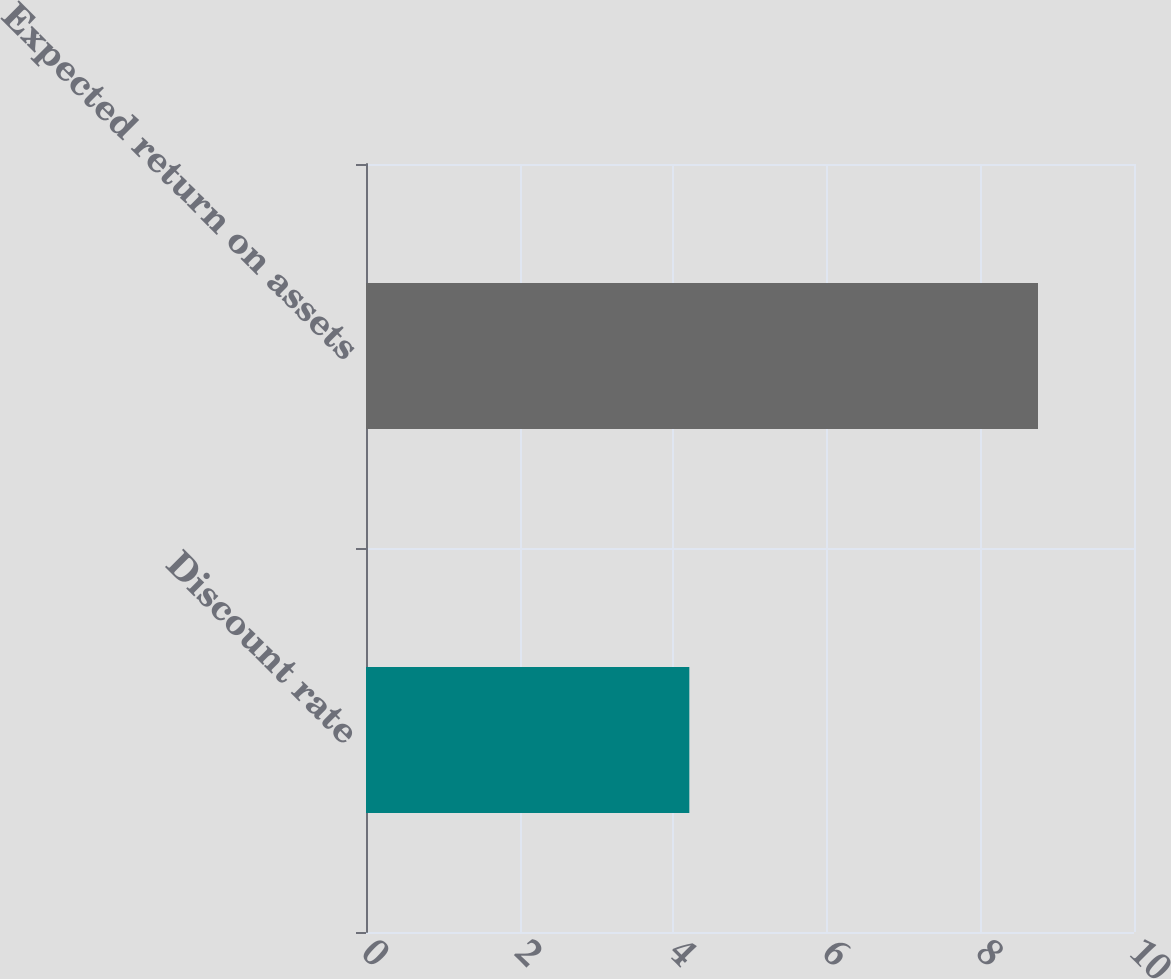Convert chart. <chart><loc_0><loc_0><loc_500><loc_500><bar_chart><fcel>Discount rate<fcel>Expected return on assets<nl><fcel>4.21<fcel>8.75<nl></chart> 